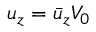<formula> <loc_0><loc_0><loc_500><loc_500>u _ { z } = \bar { u } _ { z } V _ { 0 }</formula> 